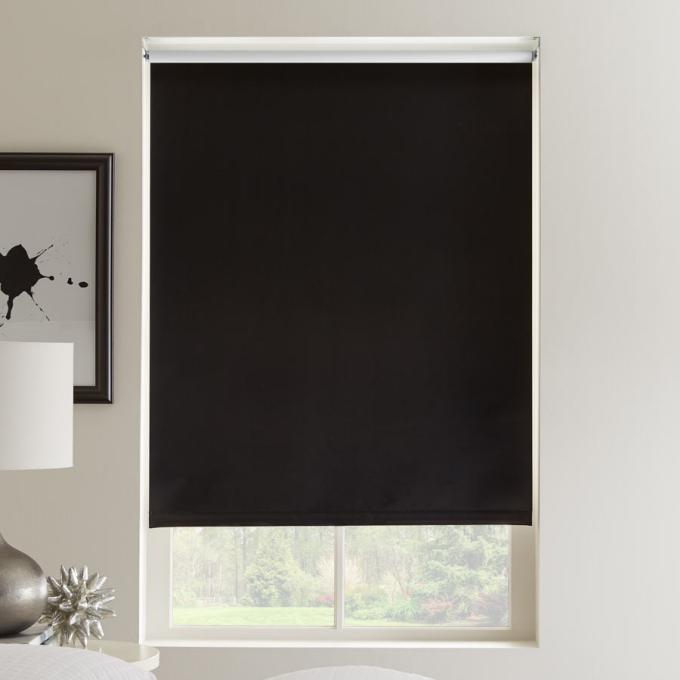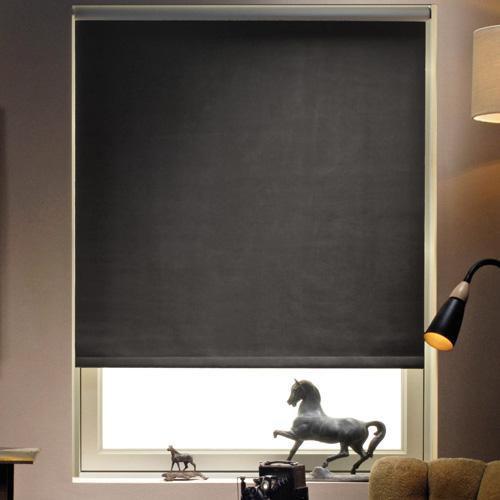The first image is the image on the left, the second image is the image on the right. Given the left and right images, does the statement "The left and right image contains the same number of blinds." hold true? Answer yes or no. Yes. The first image is the image on the left, the second image is the image on the right. Considering the images on both sides, is "At least one of the images is focused on a single window, with a black shade drawn most of the way down." valid? Answer yes or no. Yes. 